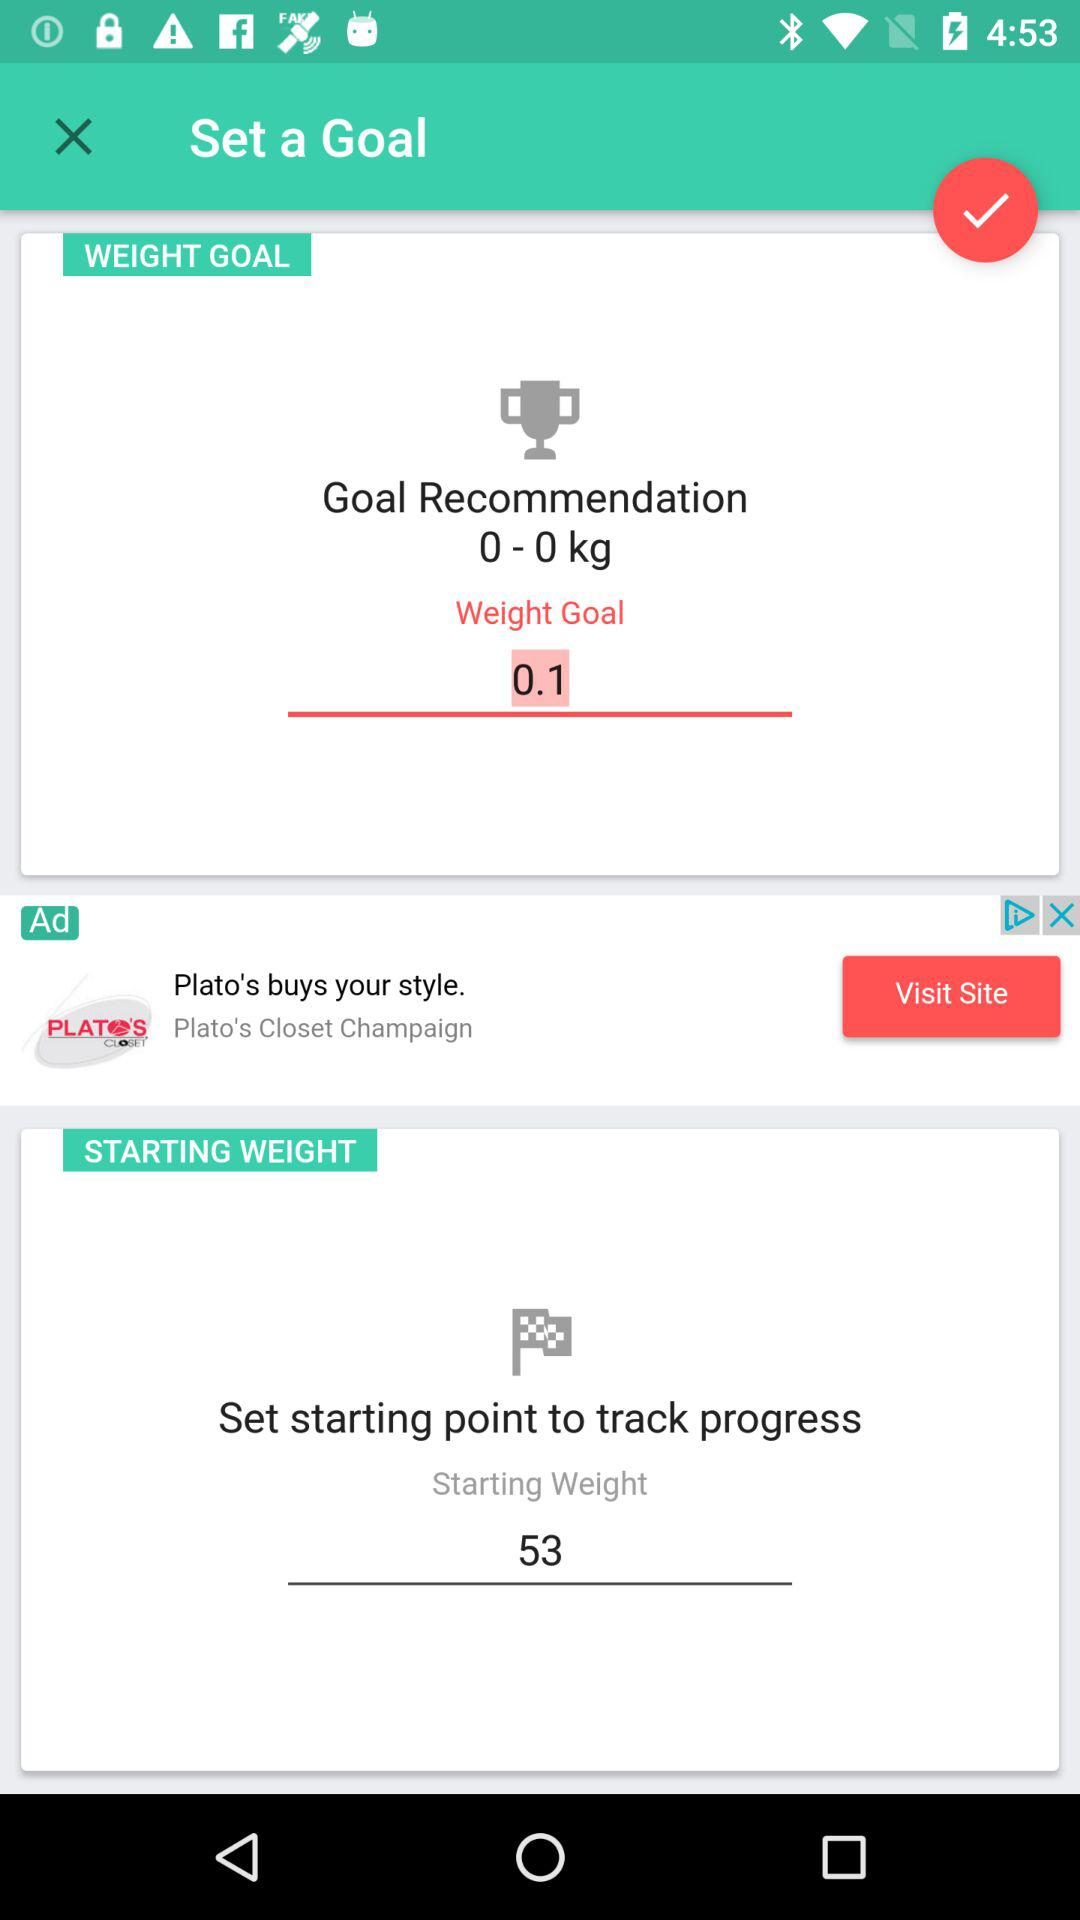What is the starting weight? The starting weight is 53. 